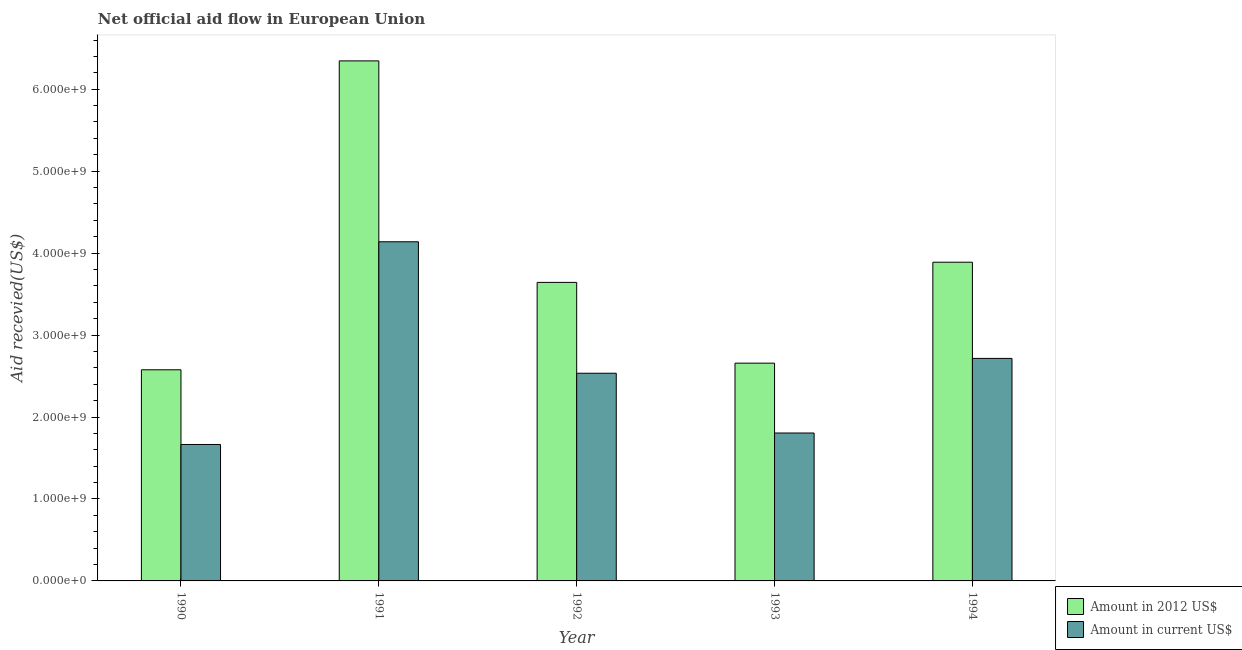How many different coloured bars are there?
Offer a terse response. 2. Are the number of bars per tick equal to the number of legend labels?
Offer a terse response. Yes. How many bars are there on the 2nd tick from the left?
Your response must be concise. 2. What is the label of the 5th group of bars from the left?
Your response must be concise. 1994. What is the amount of aid received(expressed in 2012 us$) in 1993?
Offer a very short reply. 2.66e+09. Across all years, what is the maximum amount of aid received(expressed in 2012 us$)?
Offer a terse response. 6.35e+09. Across all years, what is the minimum amount of aid received(expressed in 2012 us$)?
Offer a terse response. 2.58e+09. In which year was the amount of aid received(expressed in 2012 us$) minimum?
Offer a very short reply. 1990. What is the total amount of aid received(expressed in us$) in the graph?
Your answer should be compact. 1.29e+1. What is the difference between the amount of aid received(expressed in us$) in 1991 and that in 1992?
Keep it short and to the point. 1.60e+09. What is the difference between the amount of aid received(expressed in us$) in 1991 and the amount of aid received(expressed in 2012 us$) in 1993?
Your answer should be very brief. 2.33e+09. What is the average amount of aid received(expressed in us$) per year?
Ensure brevity in your answer.  2.57e+09. In how many years, is the amount of aid received(expressed in 2012 us$) greater than 1400000000 US$?
Your answer should be very brief. 5. What is the ratio of the amount of aid received(expressed in us$) in 1991 to that in 1993?
Provide a short and direct response. 2.29. Is the amount of aid received(expressed in 2012 us$) in 1992 less than that in 1993?
Ensure brevity in your answer.  No. What is the difference between the highest and the second highest amount of aid received(expressed in 2012 us$)?
Keep it short and to the point. 2.46e+09. What is the difference between the highest and the lowest amount of aid received(expressed in 2012 us$)?
Provide a succinct answer. 3.77e+09. What does the 2nd bar from the left in 1990 represents?
Your answer should be compact. Amount in current US$. What does the 2nd bar from the right in 1990 represents?
Offer a very short reply. Amount in 2012 US$. How many bars are there?
Give a very brief answer. 10. Are all the bars in the graph horizontal?
Ensure brevity in your answer.  No. How many years are there in the graph?
Ensure brevity in your answer.  5. Where does the legend appear in the graph?
Make the answer very short. Bottom right. What is the title of the graph?
Give a very brief answer. Net official aid flow in European Union. What is the label or title of the X-axis?
Keep it short and to the point. Year. What is the label or title of the Y-axis?
Give a very brief answer. Aid recevied(US$). What is the Aid recevied(US$) in Amount in 2012 US$ in 1990?
Offer a very short reply. 2.58e+09. What is the Aid recevied(US$) in Amount in current US$ in 1990?
Provide a short and direct response. 1.66e+09. What is the Aid recevied(US$) in Amount in 2012 US$ in 1991?
Provide a succinct answer. 6.35e+09. What is the Aid recevied(US$) of Amount in current US$ in 1991?
Make the answer very short. 4.14e+09. What is the Aid recevied(US$) of Amount in 2012 US$ in 1992?
Make the answer very short. 3.64e+09. What is the Aid recevied(US$) in Amount in current US$ in 1992?
Provide a short and direct response. 2.53e+09. What is the Aid recevied(US$) of Amount in 2012 US$ in 1993?
Your answer should be very brief. 2.66e+09. What is the Aid recevied(US$) of Amount in current US$ in 1993?
Your answer should be compact. 1.80e+09. What is the Aid recevied(US$) in Amount in 2012 US$ in 1994?
Make the answer very short. 3.89e+09. What is the Aid recevied(US$) in Amount in current US$ in 1994?
Your response must be concise. 2.71e+09. Across all years, what is the maximum Aid recevied(US$) in Amount in 2012 US$?
Ensure brevity in your answer.  6.35e+09. Across all years, what is the maximum Aid recevied(US$) in Amount in current US$?
Provide a short and direct response. 4.14e+09. Across all years, what is the minimum Aid recevied(US$) of Amount in 2012 US$?
Ensure brevity in your answer.  2.58e+09. Across all years, what is the minimum Aid recevied(US$) of Amount in current US$?
Your answer should be very brief. 1.66e+09. What is the total Aid recevied(US$) in Amount in 2012 US$ in the graph?
Your answer should be very brief. 1.91e+1. What is the total Aid recevied(US$) of Amount in current US$ in the graph?
Make the answer very short. 1.29e+1. What is the difference between the Aid recevied(US$) in Amount in 2012 US$ in 1990 and that in 1991?
Your answer should be compact. -3.77e+09. What is the difference between the Aid recevied(US$) in Amount in current US$ in 1990 and that in 1991?
Provide a short and direct response. -2.47e+09. What is the difference between the Aid recevied(US$) in Amount in 2012 US$ in 1990 and that in 1992?
Your answer should be compact. -1.07e+09. What is the difference between the Aid recevied(US$) of Amount in current US$ in 1990 and that in 1992?
Provide a short and direct response. -8.69e+08. What is the difference between the Aid recevied(US$) in Amount in 2012 US$ in 1990 and that in 1993?
Your answer should be very brief. -8.11e+07. What is the difference between the Aid recevied(US$) in Amount in current US$ in 1990 and that in 1993?
Offer a terse response. -1.40e+08. What is the difference between the Aid recevied(US$) of Amount in 2012 US$ in 1990 and that in 1994?
Provide a short and direct response. -1.31e+09. What is the difference between the Aid recevied(US$) in Amount in current US$ in 1990 and that in 1994?
Your answer should be very brief. -1.05e+09. What is the difference between the Aid recevied(US$) of Amount in 2012 US$ in 1991 and that in 1992?
Offer a very short reply. 2.70e+09. What is the difference between the Aid recevied(US$) of Amount in current US$ in 1991 and that in 1992?
Provide a short and direct response. 1.60e+09. What is the difference between the Aid recevied(US$) in Amount in 2012 US$ in 1991 and that in 1993?
Your response must be concise. 3.69e+09. What is the difference between the Aid recevied(US$) of Amount in current US$ in 1991 and that in 1993?
Offer a terse response. 2.33e+09. What is the difference between the Aid recevied(US$) of Amount in 2012 US$ in 1991 and that in 1994?
Offer a very short reply. 2.46e+09. What is the difference between the Aid recevied(US$) of Amount in current US$ in 1991 and that in 1994?
Your response must be concise. 1.42e+09. What is the difference between the Aid recevied(US$) in Amount in 2012 US$ in 1992 and that in 1993?
Make the answer very short. 9.85e+08. What is the difference between the Aid recevied(US$) in Amount in current US$ in 1992 and that in 1993?
Offer a terse response. 7.29e+08. What is the difference between the Aid recevied(US$) of Amount in 2012 US$ in 1992 and that in 1994?
Your response must be concise. -2.46e+08. What is the difference between the Aid recevied(US$) of Amount in current US$ in 1992 and that in 1994?
Your response must be concise. -1.81e+08. What is the difference between the Aid recevied(US$) in Amount in 2012 US$ in 1993 and that in 1994?
Offer a terse response. -1.23e+09. What is the difference between the Aid recevied(US$) in Amount in current US$ in 1993 and that in 1994?
Your answer should be very brief. -9.10e+08. What is the difference between the Aid recevied(US$) of Amount in 2012 US$ in 1990 and the Aid recevied(US$) of Amount in current US$ in 1991?
Provide a succinct answer. -1.56e+09. What is the difference between the Aid recevied(US$) of Amount in 2012 US$ in 1990 and the Aid recevied(US$) of Amount in current US$ in 1992?
Your answer should be very brief. 4.21e+07. What is the difference between the Aid recevied(US$) in Amount in 2012 US$ in 1990 and the Aid recevied(US$) in Amount in current US$ in 1993?
Ensure brevity in your answer.  7.71e+08. What is the difference between the Aid recevied(US$) in Amount in 2012 US$ in 1990 and the Aid recevied(US$) in Amount in current US$ in 1994?
Your answer should be very brief. -1.39e+08. What is the difference between the Aid recevied(US$) in Amount in 2012 US$ in 1991 and the Aid recevied(US$) in Amount in current US$ in 1992?
Make the answer very short. 3.81e+09. What is the difference between the Aid recevied(US$) in Amount in 2012 US$ in 1991 and the Aid recevied(US$) in Amount in current US$ in 1993?
Give a very brief answer. 4.54e+09. What is the difference between the Aid recevied(US$) in Amount in 2012 US$ in 1991 and the Aid recevied(US$) in Amount in current US$ in 1994?
Make the answer very short. 3.63e+09. What is the difference between the Aid recevied(US$) of Amount in 2012 US$ in 1992 and the Aid recevied(US$) of Amount in current US$ in 1993?
Your answer should be compact. 1.84e+09. What is the difference between the Aid recevied(US$) of Amount in 2012 US$ in 1992 and the Aid recevied(US$) of Amount in current US$ in 1994?
Give a very brief answer. 9.28e+08. What is the difference between the Aid recevied(US$) of Amount in 2012 US$ in 1993 and the Aid recevied(US$) of Amount in current US$ in 1994?
Keep it short and to the point. -5.77e+07. What is the average Aid recevied(US$) of Amount in 2012 US$ per year?
Ensure brevity in your answer.  3.82e+09. What is the average Aid recevied(US$) in Amount in current US$ per year?
Offer a terse response. 2.57e+09. In the year 1990, what is the difference between the Aid recevied(US$) in Amount in 2012 US$ and Aid recevied(US$) in Amount in current US$?
Your response must be concise. 9.11e+08. In the year 1991, what is the difference between the Aid recevied(US$) in Amount in 2012 US$ and Aid recevied(US$) in Amount in current US$?
Your response must be concise. 2.21e+09. In the year 1992, what is the difference between the Aid recevied(US$) in Amount in 2012 US$ and Aid recevied(US$) in Amount in current US$?
Your response must be concise. 1.11e+09. In the year 1993, what is the difference between the Aid recevied(US$) in Amount in 2012 US$ and Aid recevied(US$) in Amount in current US$?
Your answer should be compact. 8.53e+08. In the year 1994, what is the difference between the Aid recevied(US$) in Amount in 2012 US$ and Aid recevied(US$) in Amount in current US$?
Your answer should be compact. 1.17e+09. What is the ratio of the Aid recevied(US$) of Amount in 2012 US$ in 1990 to that in 1991?
Make the answer very short. 0.41. What is the ratio of the Aid recevied(US$) in Amount in current US$ in 1990 to that in 1991?
Your answer should be very brief. 0.4. What is the ratio of the Aid recevied(US$) of Amount in 2012 US$ in 1990 to that in 1992?
Keep it short and to the point. 0.71. What is the ratio of the Aid recevied(US$) of Amount in current US$ in 1990 to that in 1992?
Keep it short and to the point. 0.66. What is the ratio of the Aid recevied(US$) of Amount in 2012 US$ in 1990 to that in 1993?
Keep it short and to the point. 0.97. What is the ratio of the Aid recevied(US$) of Amount in current US$ in 1990 to that in 1993?
Your response must be concise. 0.92. What is the ratio of the Aid recevied(US$) in Amount in 2012 US$ in 1990 to that in 1994?
Provide a succinct answer. 0.66. What is the ratio of the Aid recevied(US$) in Amount in current US$ in 1990 to that in 1994?
Offer a very short reply. 0.61. What is the ratio of the Aid recevied(US$) of Amount in 2012 US$ in 1991 to that in 1992?
Offer a terse response. 1.74. What is the ratio of the Aid recevied(US$) in Amount in current US$ in 1991 to that in 1992?
Your answer should be very brief. 1.63. What is the ratio of the Aid recevied(US$) of Amount in 2012 US$ in 1991 to that in 1993?
Your response must be concise. 2.39. What is the ratio of the Aid recevied(US$) of Amount in current US$ in 1991 to that in 1993?
Offer a terse response. 2.29. What is the ratio of the Aid recevied(US$) in Amount in 2012 US$ in 1991 to that in 1994?
Provide a succinct answer. 1.63. What is the ratio of the Aid recevied(US$) in Amount in current US$ in 1991 to that in 1994?
Keep it short and to the point. 1.52. What is the ratio of the Aid recevied(US$) of Amount in 2012 US$ in 1992 to that in 1993?
Make the answer very short. 1.37. What is the ratio of the Aid recevied(US$) of Amount in current US$ in 1992 to that in 1993?
Offer a very short reply. 1.4. What is the ratio of the Aid recevied(US$) of Amount in 2012 US$ in 1992 to that in 1994?
Give a very brief answer. 0.94. What is the ratio of the Aid recevied(US$) of Amount in current US$ in 1992 to that in 1994?
Offer a terse response. 0.93. What is the ratio of the Aid recevied(US$) of Amount in 2012 US$ in 1993 to that in 1994?
Offer a very short reply. 0.68. What is the ratio of the Aid recevied(US$) of Amount in current US$ in 1993 to that in 1994?
Keep it short and to the point. 0.66. What is the difference between the highest and the second highest Aid recevied(US$) of Amount in 2012 US$?
Provide a short and direct response. 2.46e+09. What is the difference between the highest and the second highest Aid recevied(US$) in Amount in current US$?
Offer a very short reply. 1.42e+09. What is the difference between the highest and the lowest Aid recevied(US$) of Amount in 2012 US$?
Give a very brief answer. 3.77e+09. What is the difference between the highest and the lowest Aid recevied(US$) in Amount in current US$?
Provide a succinct answer. 2.47e+09. 